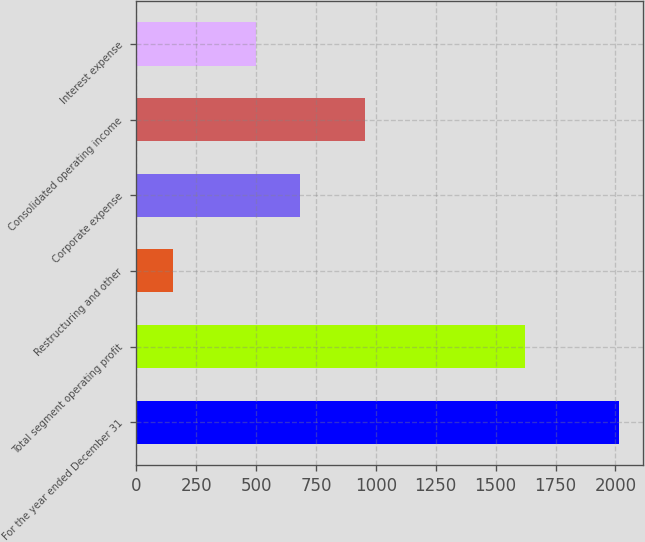Convert chart. <chart><loc_0><loc_0><loc_500><loc_500><bar_chart><fcel>For the year ended December 31<fcel>Total segment operating profit<fcel>Restructuring and other<fcel>Corporate expense<fcel>Consolidated operating income<fcel>Interest expense<nl><fcel>2016<fcel>1622<fcel>155<fcel>685.1<fcel>954<fcel>499<nl></chart> 